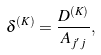<formula> <loc_0><loc_0><loc_500><loc_500>\delta ^ { ( K ) } = \frac { D ^ { ( K ) } } { A _ { j ^ { \prime } j } } ,</formula> 